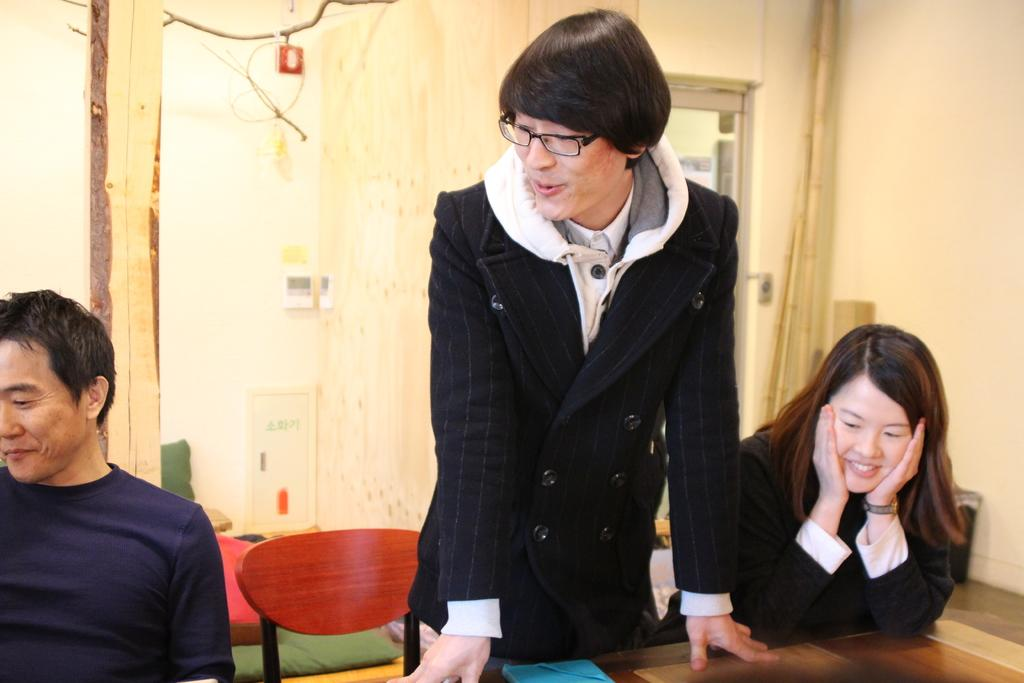What is the main subject of the image? There is a person standing at the center of the image. Are there any other people in the image? Yes, people are sitting on the left and right sides of the standing person. What is in front of the people? There is a table in front of the people. What type of bread can be seen on the rail in the image? There is no bread or rail present in the image. 